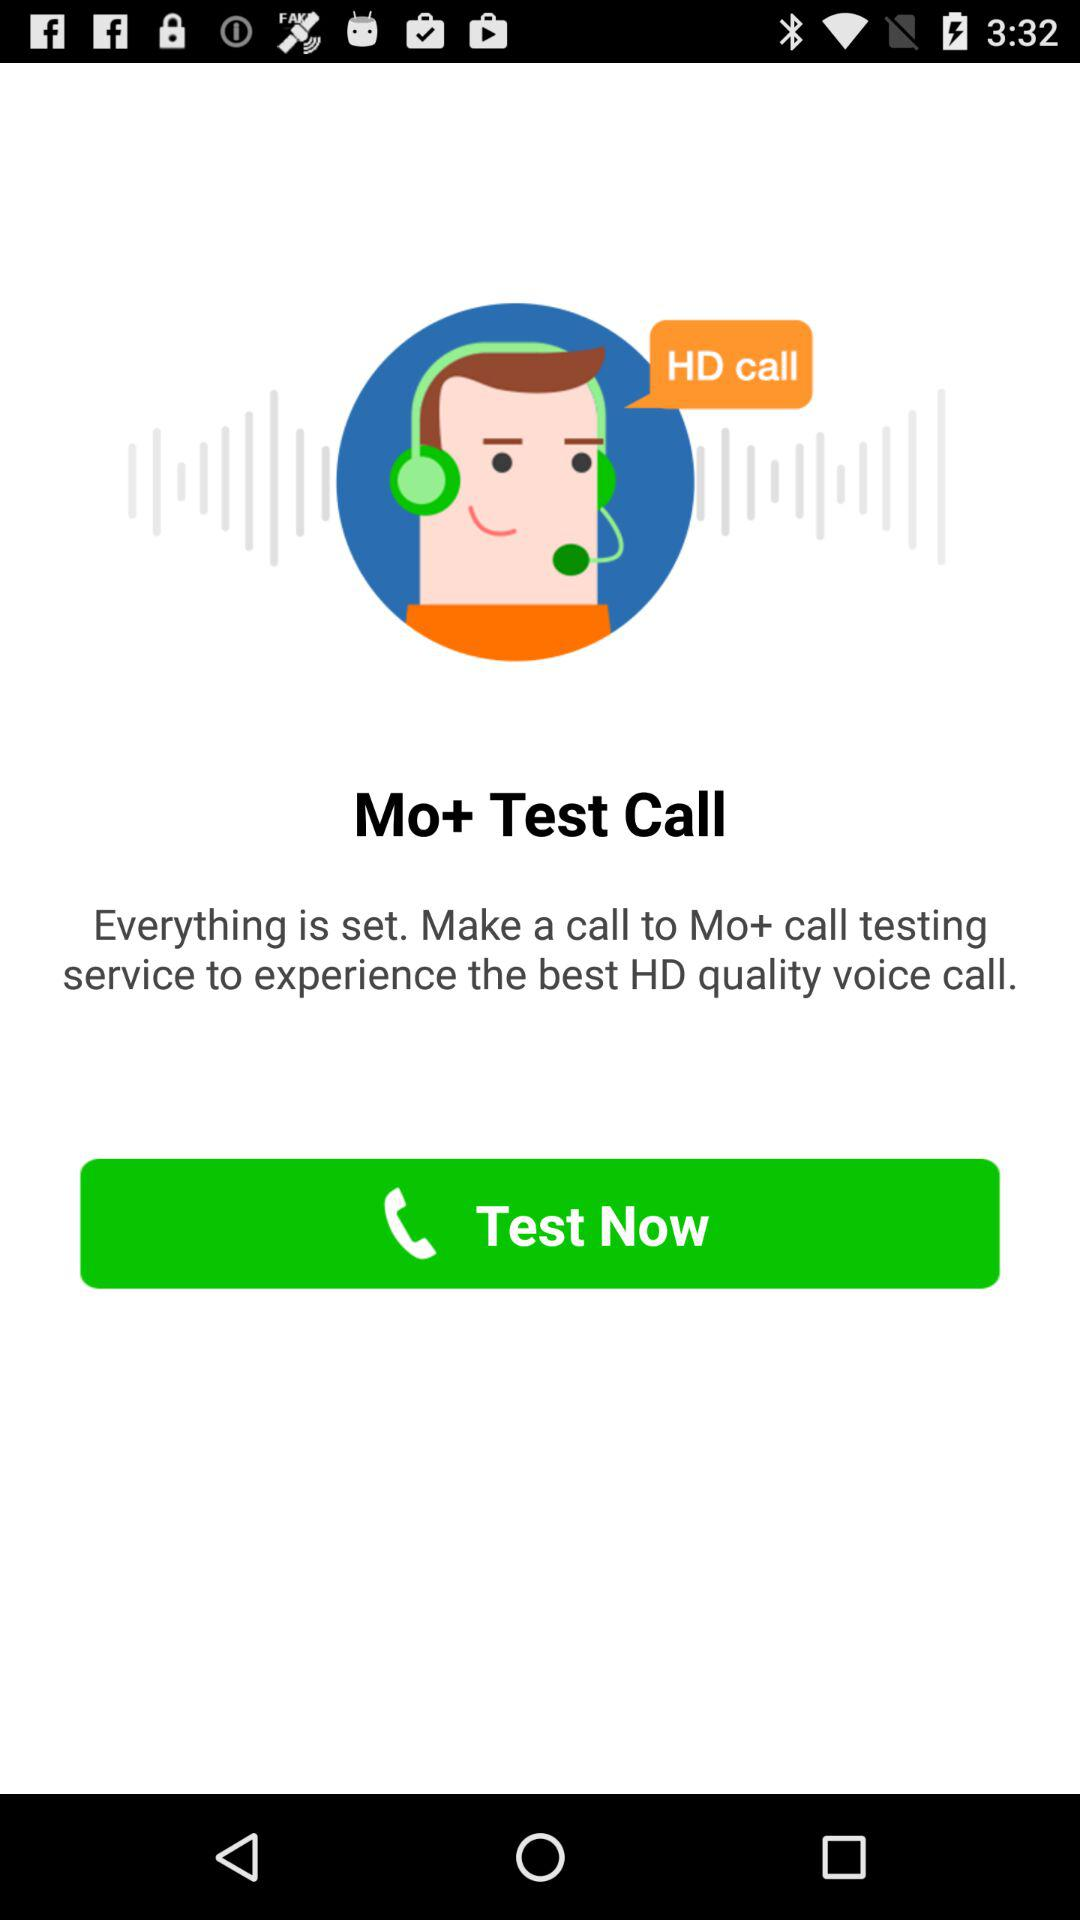How can we experience the best HD quality voice call? You can experience the best HD quality voice call by making a call to the Mo+ call testing service. 